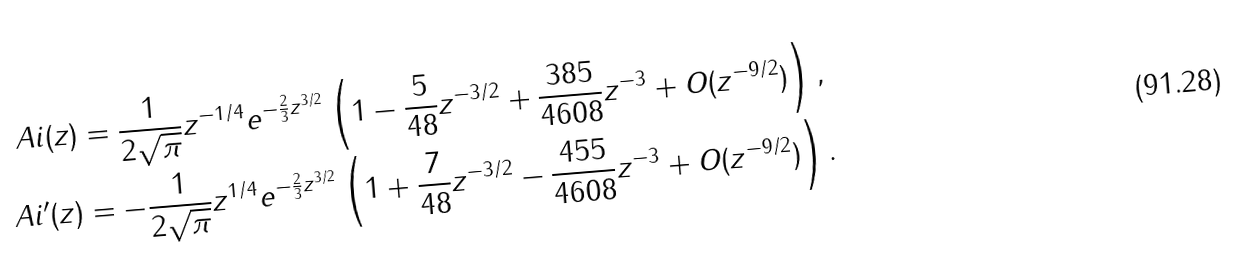Convert formula to latex. <formula><loc_0><loc_0><loc_500><loc_500>\ A i ( z ) & = \frac { 1 } { 2 \sqrt { \pi } } z ^ { - 1 / 4 } e ^ { - \frac { 2 } { 3 } z ^ { 3 / 2 } } \left ( 1 - \frac { 5 } { 4 8 } z ^ { - 3 / 2 } + \frac { 3 8 5 } { 4 6 0 8 } z ^ { - 3 } + O ( z ^ { - 9 / 2 } ) \right ) , \\ \ A i ^ { \prime } ( z ) & = - \frac { 1 } { 2 \sqrt { \pi } } z ^ { 1 / 4 } e ^ { - \frac { 2 } { 3 } z ^ { 3 / 2 } } \left ( 1 + \frac { 7 } { 4 8 } z ^ { - 3 / 2 } - \frac { 4 5 5 } { 4 6 0 8 } z ^ { - 3 } + O ( z ^ { - 9 / 2 } ) \right ) .</formula> 